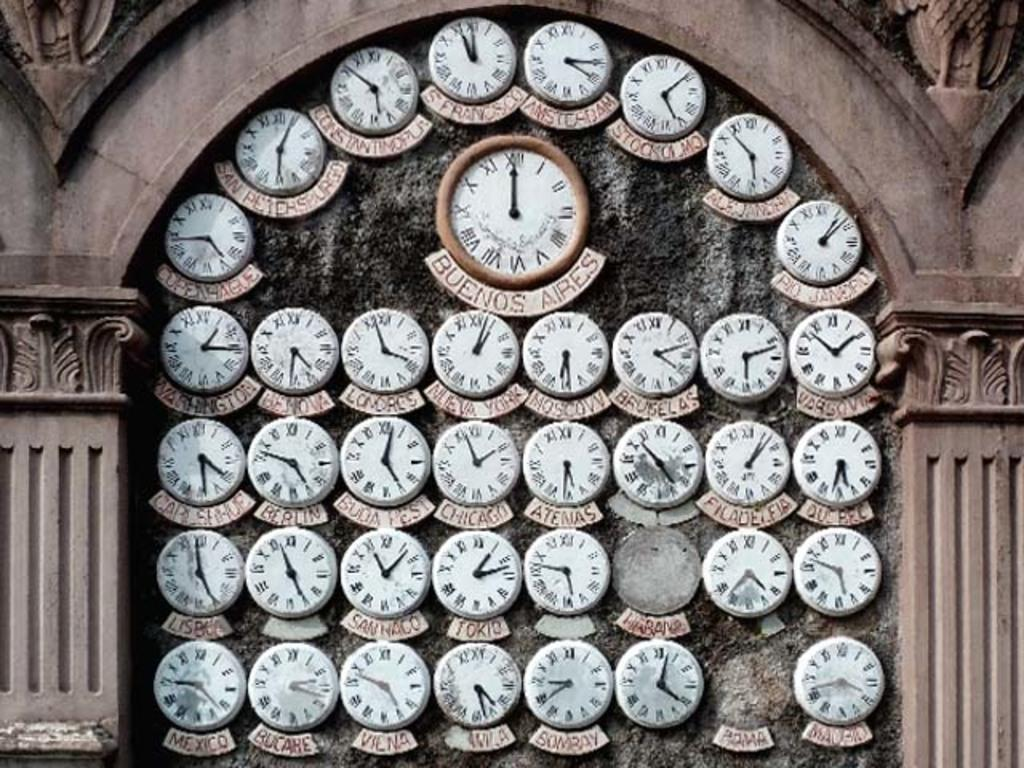<image>
Write a terse but informative summary of the picture. A wall of clocks that show the time in different cities and it is 12:00 in Buenos Aires. 